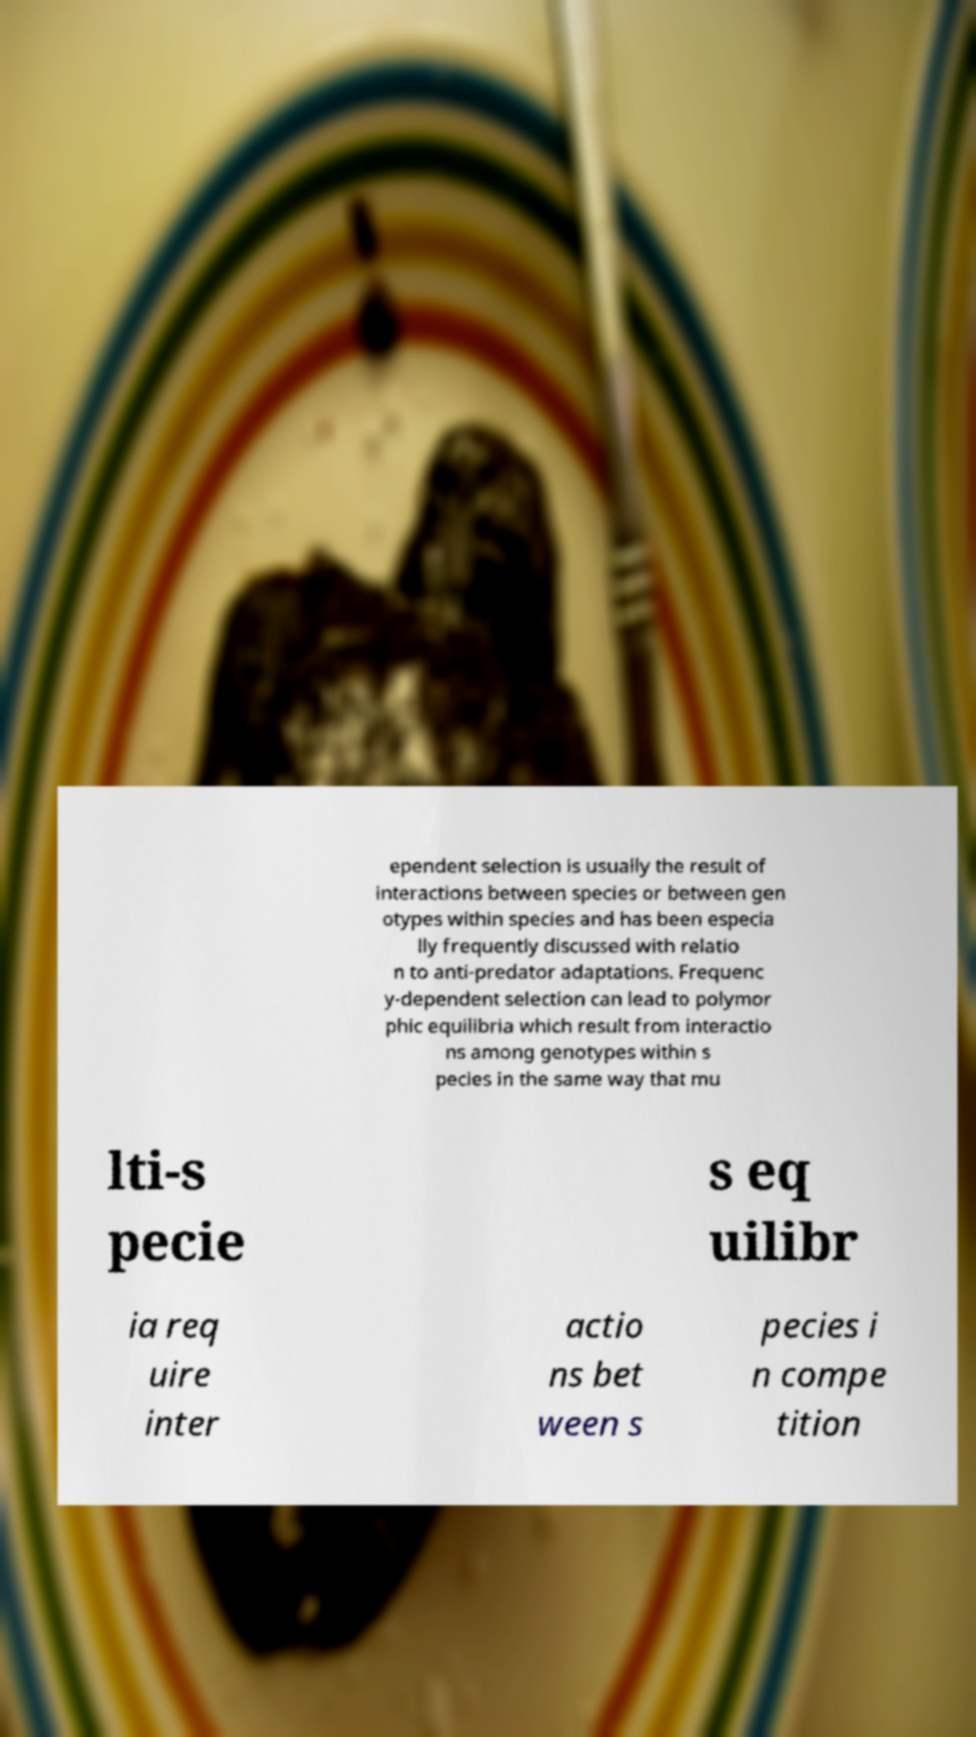Please read and relay the text visible in this image. What does it say? ependent selection is usually the result of interactions between species or between gen otypes within species and has been especia lly frequently discussed with relatio n to anti-predator adaptations. Frequenc y-dependent selection can lead to polymor phic equilibria which result from interactio ns among genotypes within s pecies in the same way that mu lti-s pecie s eq uilibr ia req uire inter actio ns bet ween s pecies i n compe tition 